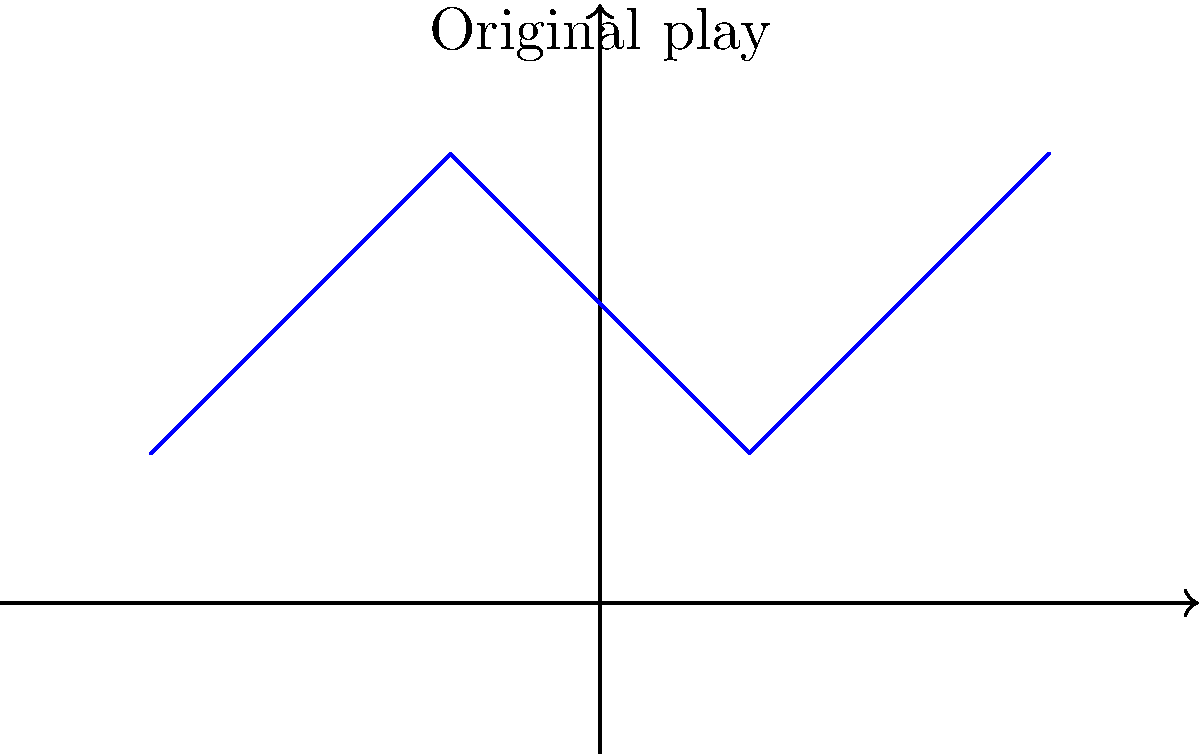A famous play from the 1954 championship game is represented by the blue line segments connecting points A, B, C, and D. If this play is reflected across the field's center line (x-axis), what will be the coordinates of point C' in the reflected play? To find the coordinates of point C' after reflecting the play across the field's center line (x-axis), we can follow these steps:

1. Identify the original coordinates of point C:
   Point C has coordinates (1, 1)

2. Understand the reflection process:
   When reflecting a point across the x-axis, the x-coordinate remains the same, while the y-coordinate changes sign.

3. Apply the reflection:
   - The x-coordinate of C' will be the same as C: 1
   - The y-coordinate of C' will be the negative of C's y-coordinate: -1

4. Combine the new coordinates:
   C' will have coordinates (1, -1)

Therefore, after reflection, point C' will be located at coordinates (1, -1).
Answer: (1, -1) 